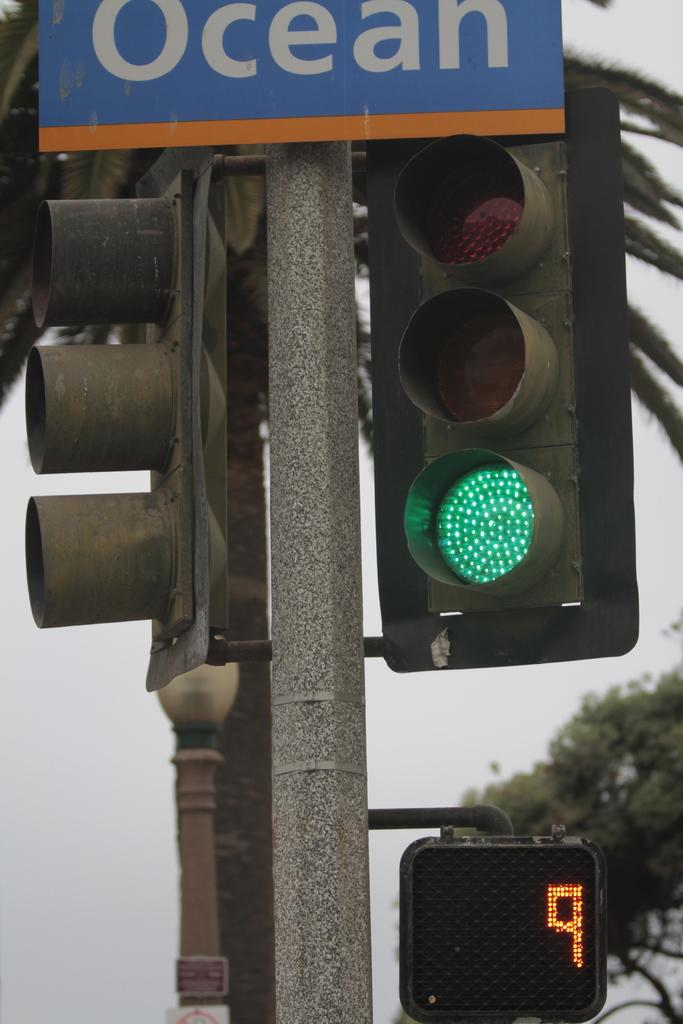<image>
Share a concise interpretation of the image provided. Above a green traffic light is a sign that reads "ocean" 